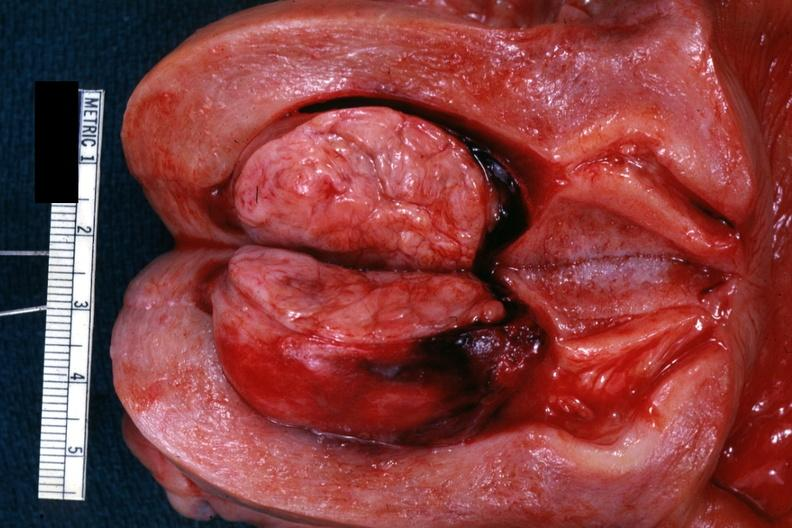s leiomyoma present?
Answer the question using a single word or phrase. Yes 